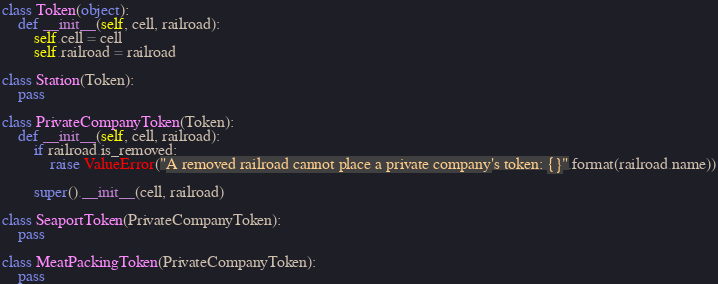Convert code to text. <code><loc_0><loc_0><loc_500><loc_500><_Python_>class Token(object):
    def __init__(self, cell, railroad):
        self.cell = cell
        self.railroad = railroad

class Station(Token):
    pass

class PrivateCompanyToken(Token):
    def __init__(self, cell, railroad):
        if railroad.is_removed:
            raise ValueError("A removed railroad cannot place a private company's token: {}".format(railroad.name))

        super().__init__(cell, railroad)

class SeaportToken(PrivateCompanyToken):
    pass

class MeatPackingToken(PrivateCompanyToken):
    pass</code> 